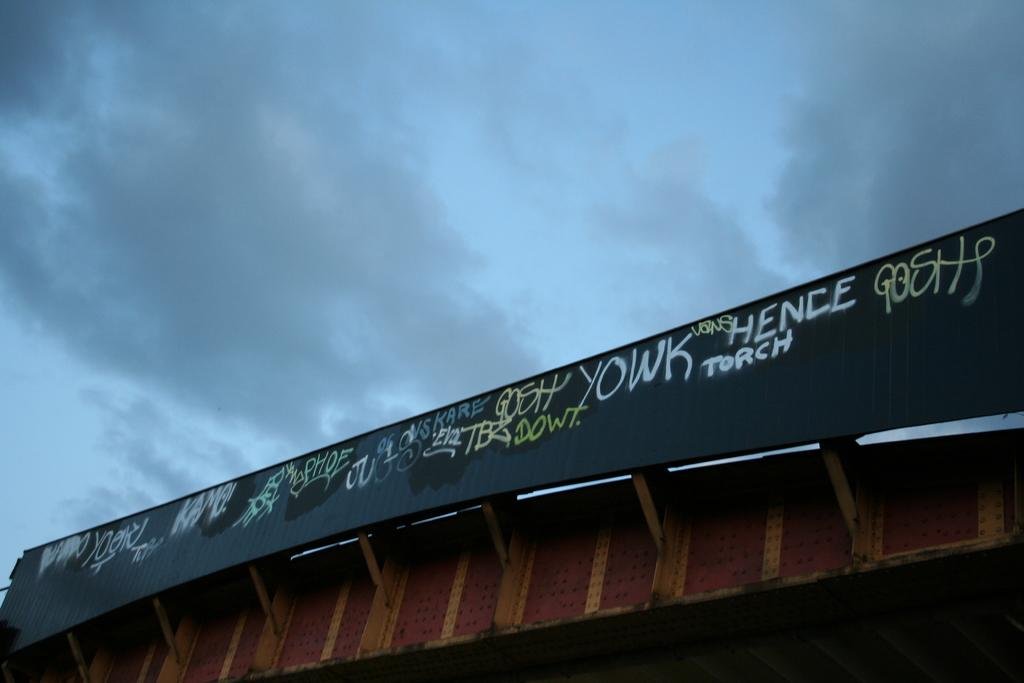<image>
Offer a succinct explanation of the picture presented. graffiti on a road construction beam says YOWK and Hence 